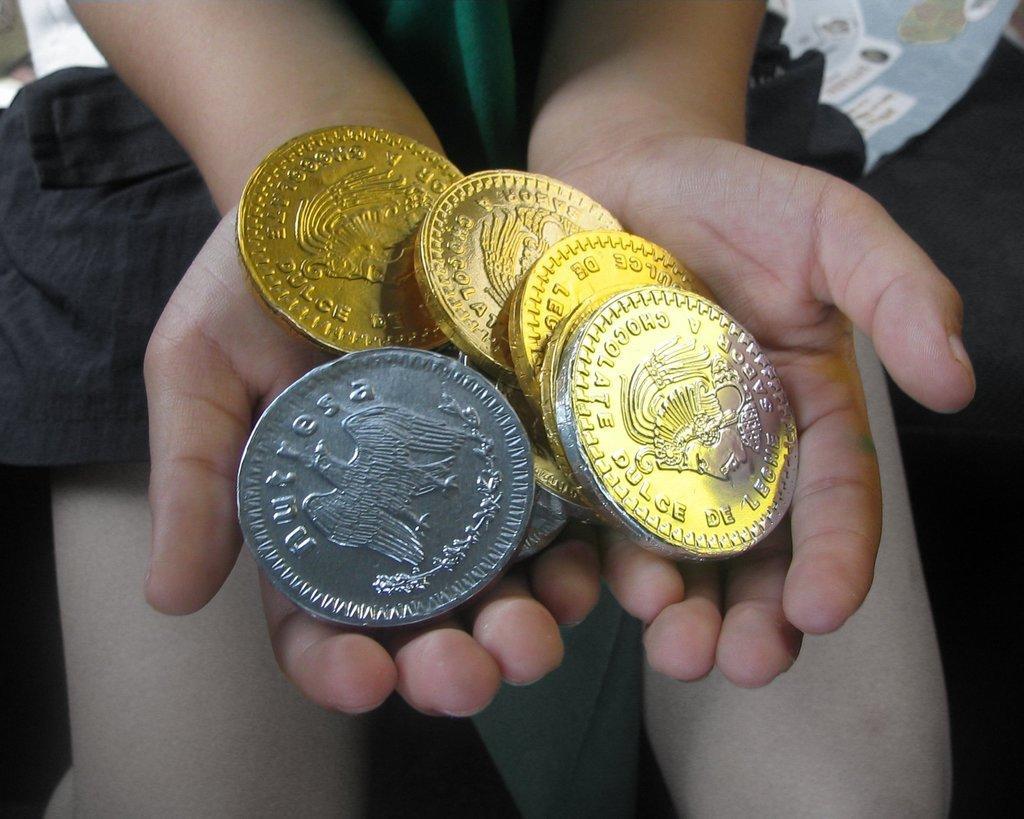Describe this image in one or two sentences. In the center of the image we can see a person is holding the coins. 